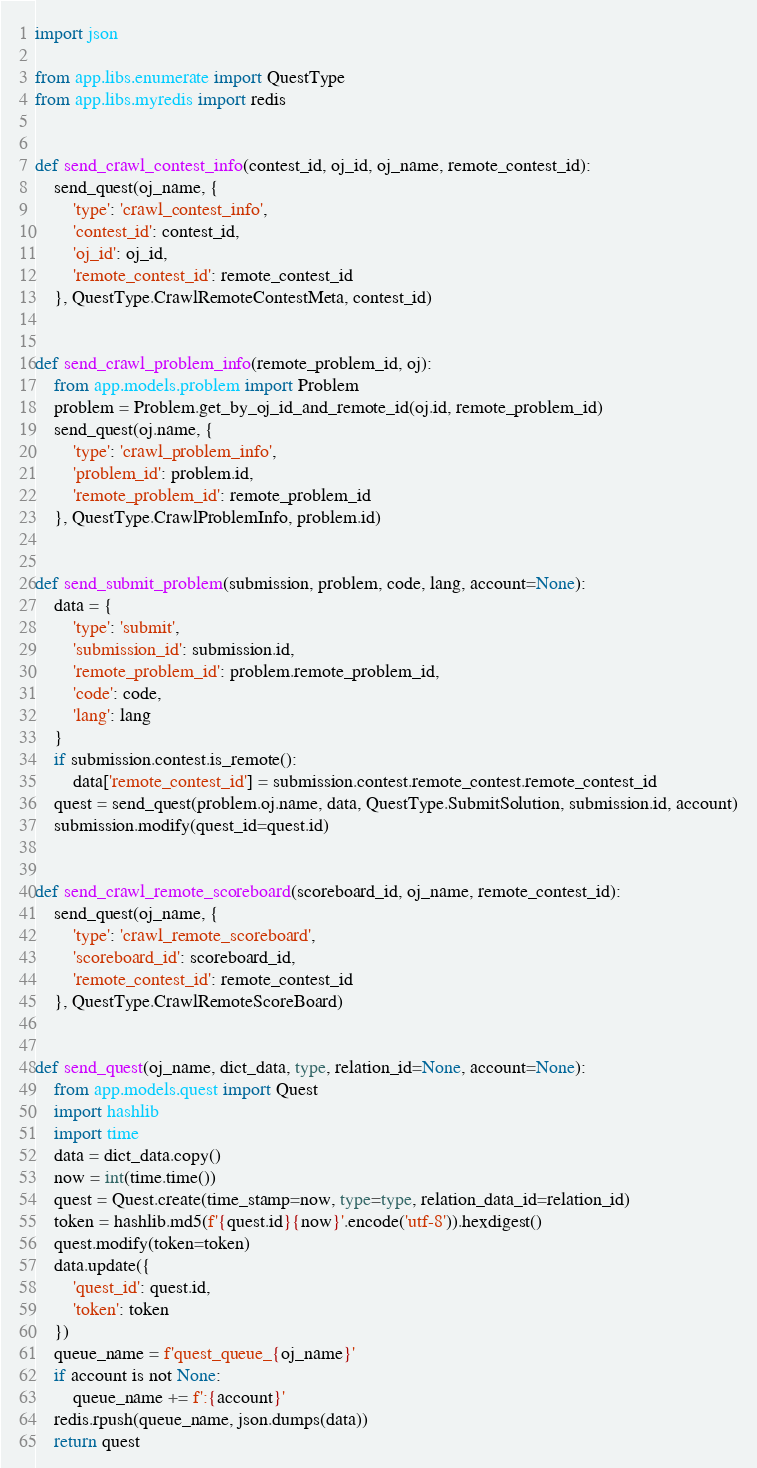Convert code to text. <code><loc_0><loc_0><loc_500><loc_500><_Python_>import json

from app.libs.enumerate import QuestType
from app.libs.myredis import redis


def send_crawl_contest_info(contest_id, oj_id, oj_name, remote_contest_id):
    send_quest(oj_name, {
        'type': 'crawl_contest_info',
        'contest_id': contest_id,
        'oj_id': oj_id,
        'remote_contest_id': remote_contest_id
    }, QuestType.CrawlRemoteContestMeta, contest_id)


def send_crawl_problem_info(remote_problem_id, oj):
    from app.models.problem import Problem
    problem = Problem.get_by_oj_id_and_remote_id(oj.id, remote_problem_id)
    send_quest(oj.name, {
        'type': 'crawl_problem_info',
        'problem_id': problem.id,
        'remote_problem_id': remote_problem_id
    }, QuestType.CrawlProblemInfo, problem.id)


def send_submit_problem(submission, problem, code, lang, account=None):
    data = {
        'type': 'submit',
        'submission_id': submission.id,
        'remote_problem_id': problem.remote_problem_id,
        'code': code,
        'lang': lang
    }
    if submission.contest.is_remote():
        data['remote_contest_id'] = submission.contest.remote_contest.remote_contest_id
    quest = send_quest(problem.oj.name, data, QuestType.SubmitSolution, submission.id, account)
    submission.modify(quest_id=quest.id)


def send_crawl_remote_scoreboard(scoreboard_id, oj_name, remote_contest_id):
    send_quest(oj_name, {
        'type': 'crawl_remote_scoreboard',
        'scoreboard_id': scoreboard_id,
        'remote_contest_id': remote_contest_id
    }, QuestType.CrawlRemoteScoreBoard)


def send_quest(oj_name, dict_data, type, relation_id=None, account=None):
    from app.models.quest import Quest
    import hashlib
    import time
    data = dict_data.copy()
    now = int(time.time())
    quest = Quest.create(time_stamp=now, type=type, relation_data_id=relation_id)
    token = hashlib.md5(f'{quest.id}{now}'.encode('utf-8')).hexdigest()
    quest.modify(token=token)
    data.update({
        'quest_id': quest.id,
        'token': token
    })
    queue_name = f'quest_queue_{oj_name}'
    if account is not None:
        queue_name += f':{account}'
    redis.rpush(queue_name, json.dumps(data))
    return quest
</code> 